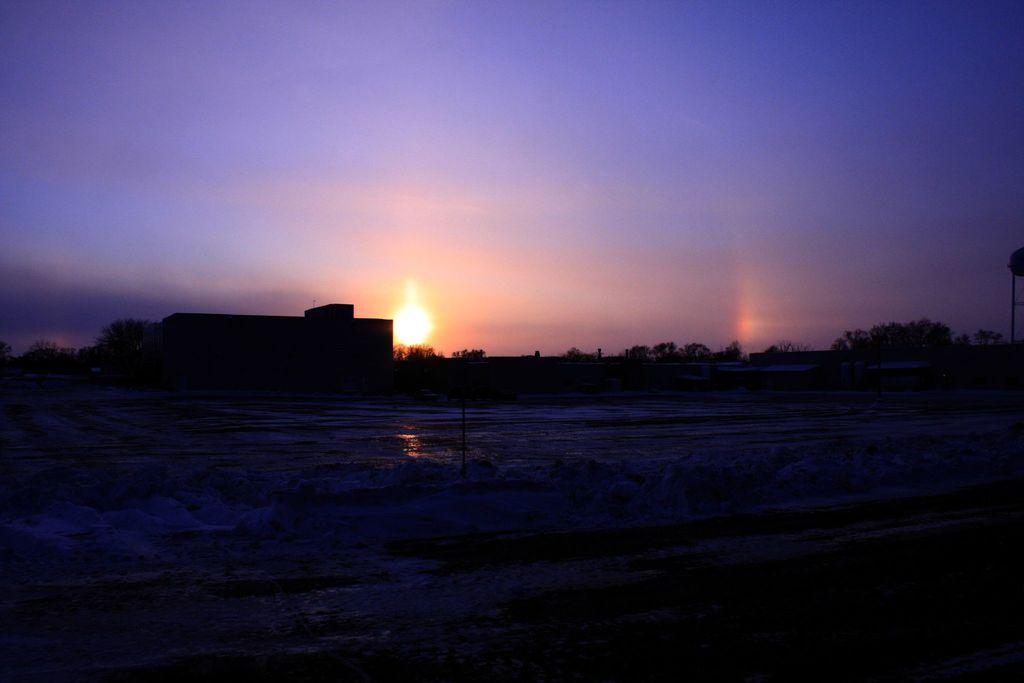What type of structure is present in the image? There is a building in the image. What can be seen in the sky in the image? The sun is visible in the sky. What type of vegetation is present in the image? There are many trees in the image. What type of cheese is being used to construct the building in the image? There is no cheese present in the image; the building is not made of cheese. 